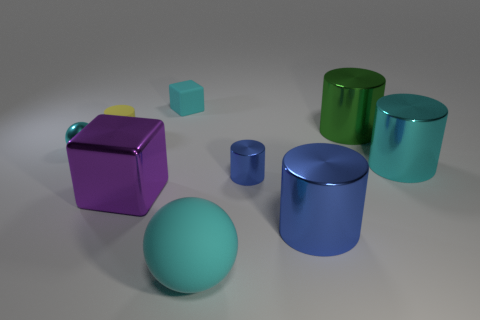How does the lighting in the image affect the appearance of these objects? The lighting in the image is soft and diffused, casting gentle shadows and giving the objects a smooth appearance. It emphasizes the metallic sheen of the spheres and cylinders, while the matte cubes absorb the light, showcasing their colors without reflective glare. 